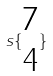<formula> <loc_0><loc_0><loc_500><loc_500>s \{ \begin{matrix} 7 \\ 4 \end{matrix} \}</formula> 